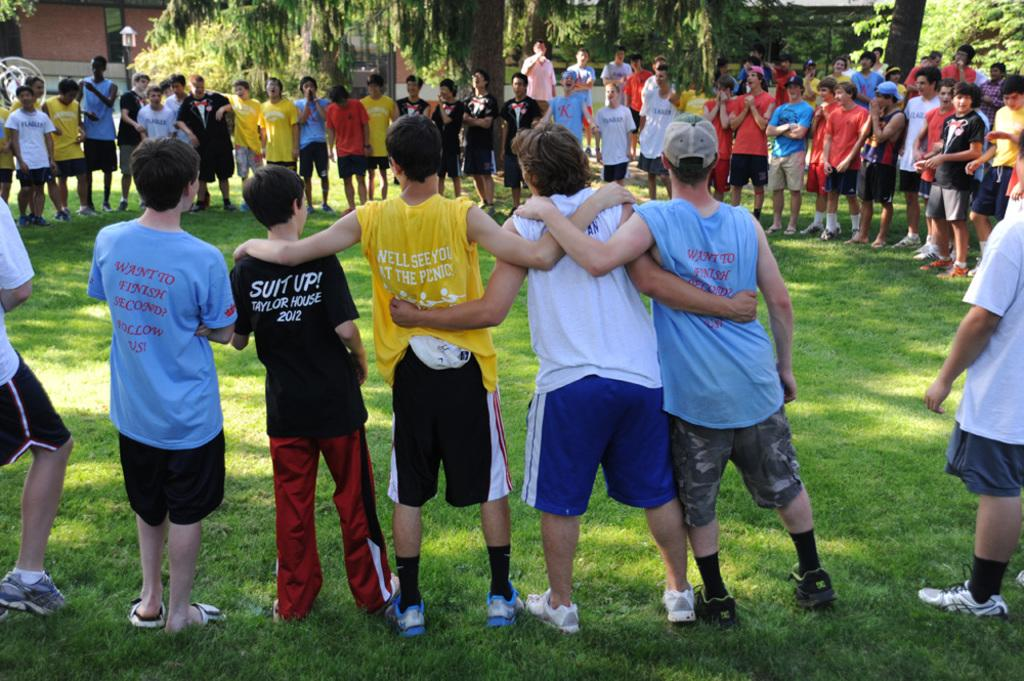<image>
Write a terse but informative summary of the picture. People hugging with a man wearing a shirt which says "Want to". 